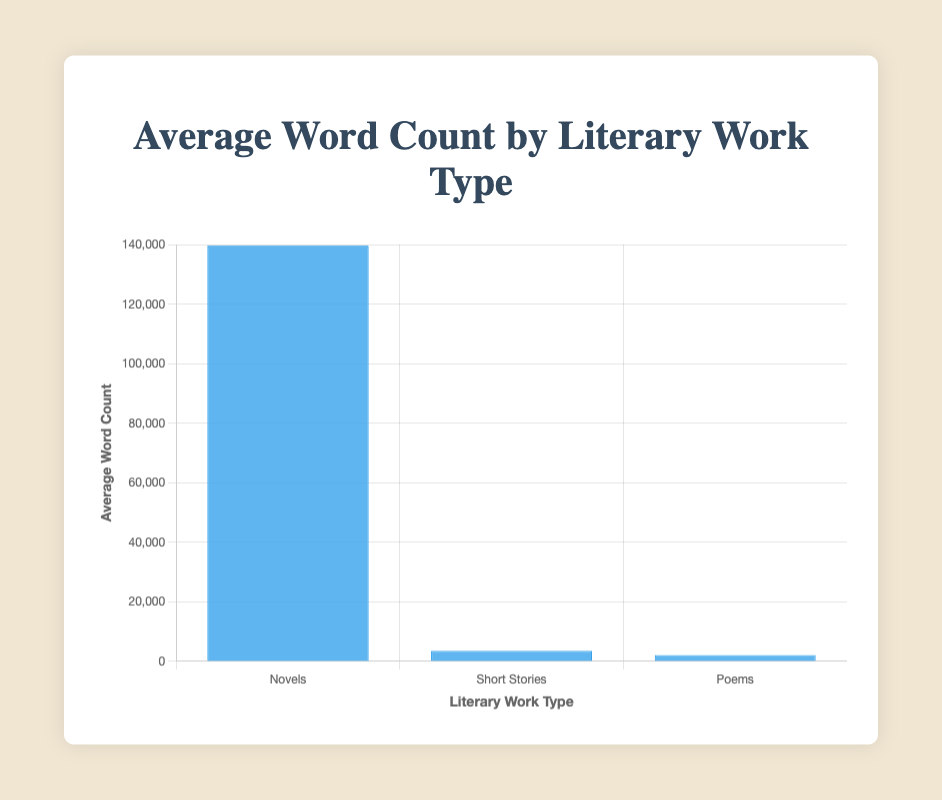Which type of literary work has the highest average word count? The bar representing "Novels" is the highest among the three types, indicating that novels have the highest average word count.
Answer: Novels How does the average word count of short stories compare to poems? The bar for "Short Stories" is higher than the bar for "Poems," indicating that short stories have a higher average word count compared to poems.
Answer: Short stories are higher By approximately how much does the average word count of novels exceed the average word count of short stories? The average word count of novels is approximately 139686.33, while for short stories it is 3516.67. Subtracting the two gives 136169.66.
Answer: 136170 What is the combined average word count of poems and short stories? The average word count of short stories is 3516.67, and for poems, it is 2081. Starting by adding these two gives 5597.67.
Answer: 5597.67 Which type of literary work shows the smallest average word count? The smallest bar corresponds to "Poems," indicating that poems have the smallest average word count.
Answer: Poems What is the ratio of the average word count of novels to the average word count of poems? The average word count of novels is approximately 139686.33, and for poems, it is 2081. Dividing the former by the latter gives about 67.13.
Answer: 67.13 If the average word counts of novels, short stories, and poems are written from highest to lowest, what would be the order? By observing the bar heights, the order from highest to lowest is novels, short stories, and poems.
Answer: Novels, Short Stories, Poems Comparing the visual lengths, if we were to combine the average word counts of short stories and poems, would their sum surpass the average word count of novels? The combined average word count of short stories and poems is 5597.67. The average word count of novels is about 139686.33. Clearly, the sum (5597.67) is far less than 139686.33.
Answer: No What is the approximate difference in the average word count between novels and poems? The average word count of novels is approximately 139686.33, and for poems, it is 2081. Subtracting 2081 from 139686.33 gives about 137605.33.
Answer: 137605.33 